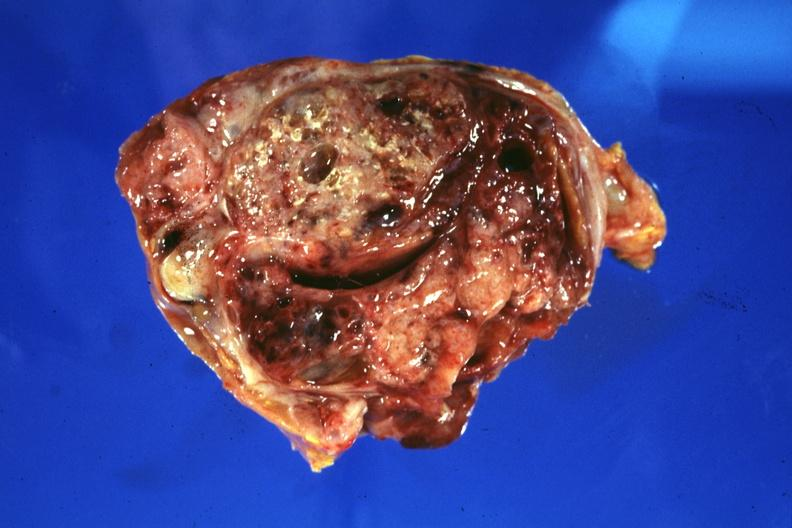does this image show cross section of tumor?
Answer the question using a single word or phrase. Yes 